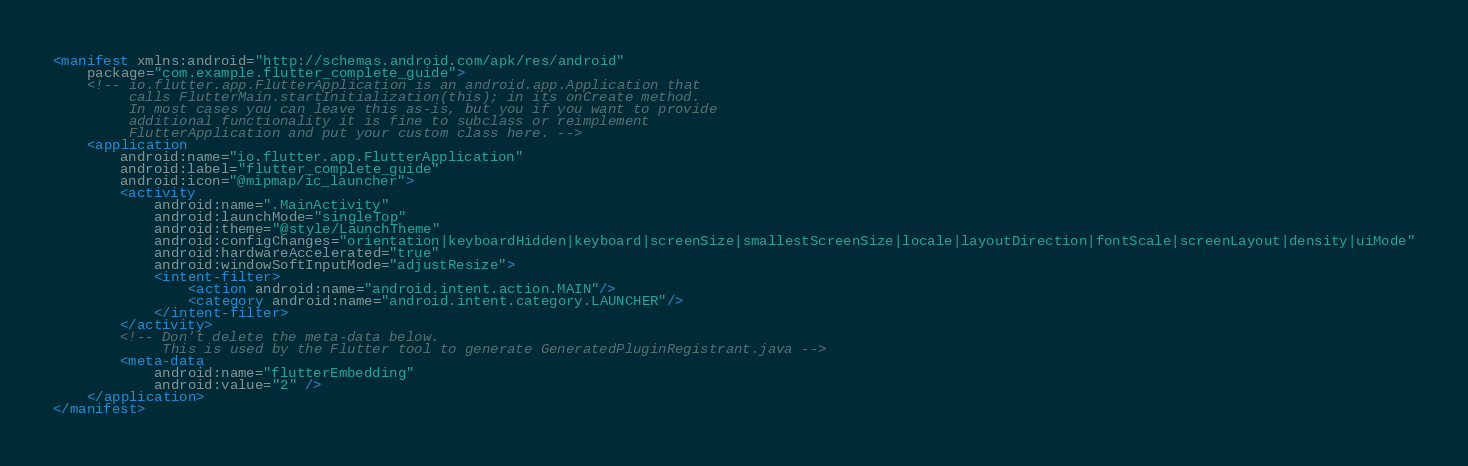<code> <loc_0><loc_0><loc_500><loc_500><_XML_><manifest xmlns:android="http://schemas.android.com/apk/res/android"
    package="com.example.flutter_complete_guide">
    <!-- io.flutter.app.FlutterApplication is an android.app.Application that
         calls FlutterMain.startInitialization(this); in its onCreate method.
         In most cases you can leave this as-is, but you if you want to provide
         additional functionality it is fine to subclass or reimplement
         FlutterApplication and put your custom class here. -->
    <application
        android:name="io.flutter.app.FlutterApplication"
        android:label="flutter_complete_guide"
        android:icon="@mipmap/ic_launcher">
        <activity
            android:name=".MainActivity"
            android:launchMode="singleTop"
            android:theme="@style/LaunchTheme"
            android:configChanges="orientation|keyboardHidden|keyboard|screenSize|smallestScreenSize|locale|layoutDirection|fontScale|screenLayout|density|uiMode"
            android:hardwareAccelerated="true"
            android:windowSoftInputMode="adjustResize">
            <intent-filter>
                <action android:name="android.intent.action.MAIN"/>
                <category android:name="android.intent.category.LAUNCHER"/>
            </intent-filter>
        </activity>
        <!-- Don't delete the meta-data below.
             This is used by the Flutter tool to generate GeneratedPluginRegistrant.java -->
        <meta-data
            android:name="flutterEmbedding"
            android:value="2" />
    </application>
</manifest>
</code> 